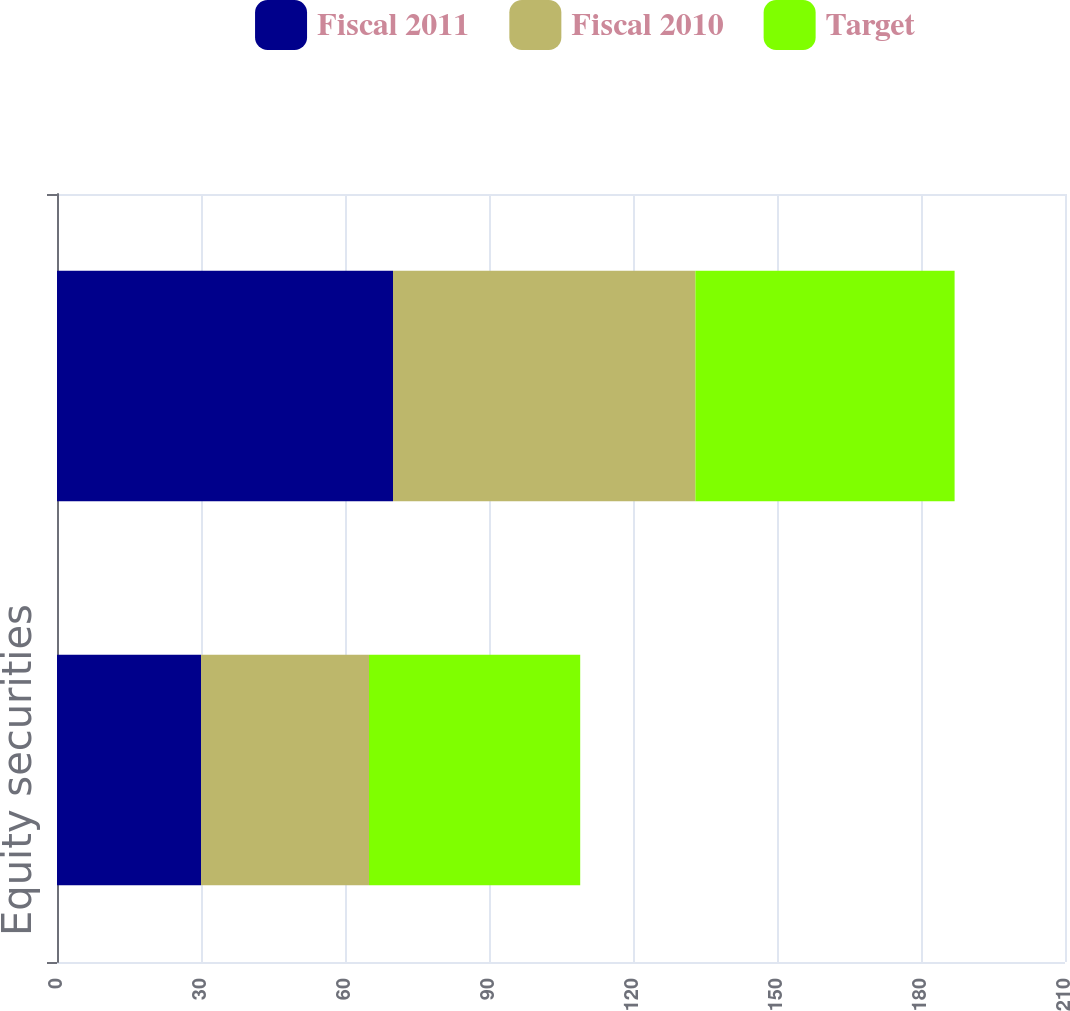<chart> <loc_0><loc_0><loc_500><loc_500><stacked_bar_chart><ecel><fcel>Equity securities<fcel>Debt securities<nl><fcel>Fiscal 2011<fcel>30<fcel>70<nl><fcel>Fiscal 2010<fcel>35<fcel>63<nl><fcel>Target<fcel>44<fcel>54<nl></chart> 